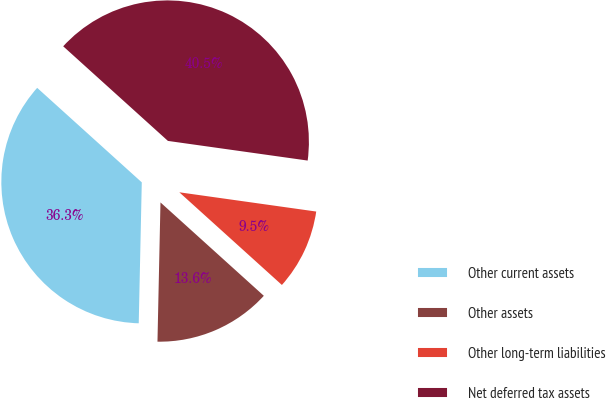Convert chart to OTSL. <chart><loc_0><loc_0><loc_500><loc_500><pie_chart><fcel>Other current assets<fcel>Other assets<fcel>Other long-term liabilities<fcel>Net deferred tax assets<nl><fcel>36.35%<fcel>13.65%<fcel>9.47%<fcel>40.53%<nl></chart> 